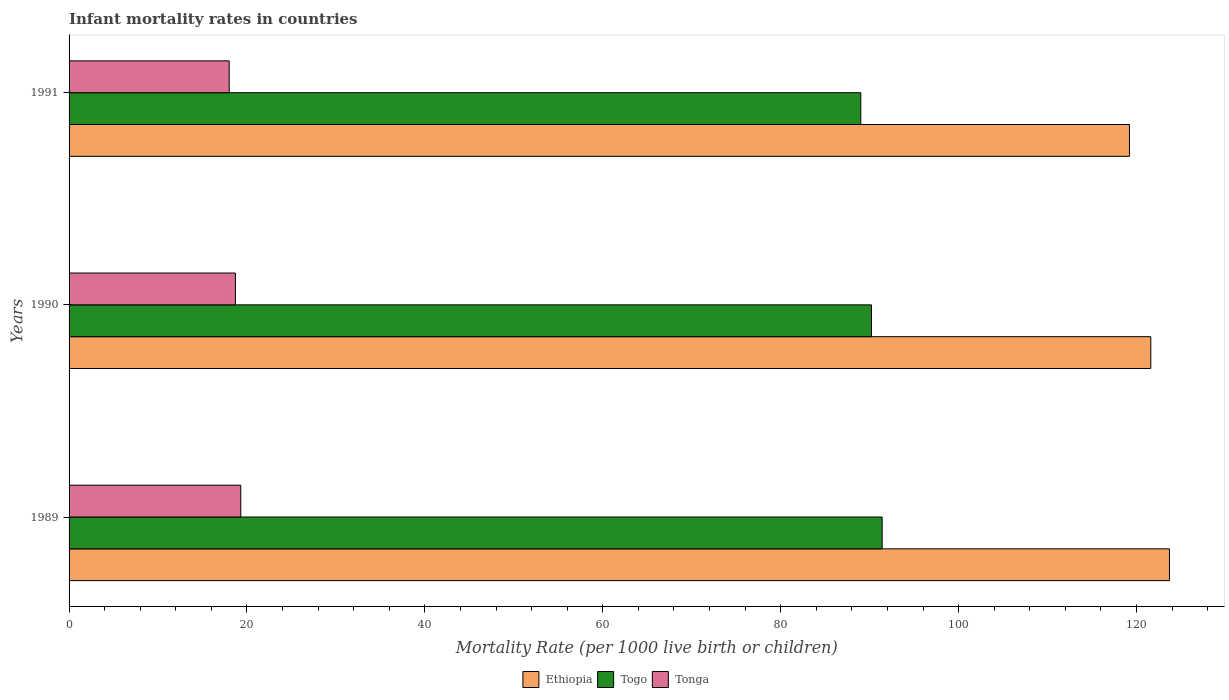How many groups of bars are there?
Provide a succinct answer. 3. Are the number of bars on each tick of the Y-axis equal?
Your answer should be very brief. Yes. How many bars are there on the 2nd tick from the top?
Make the answer very short. 3. How many bars are there on the 3rd tick from the bottom?
Provide a succinct answer. 3. What is the label of the 2nd group of bars from the top?
Ensure brevity in your answer.  1990. What is the infant mortality rate in Togo in 1989?
Offer a terse response. 91.4. Across all years, what is the maximum infant mortality rate in Tonga?
Give a very brief answer. 19.3. Across all years, what is the minimum infant mortality rate in Togo?
Offer a very short reply. 89. In which year was the infant mortality rate in Ethiopia maximum?
Provide a succinct answer. 1989. What is the total infant mortality rate in Ethiopia in the graph?
Provide a short and direct response. 364.5. What is the difference between the infant mortality rate in Tonga in 1989 and that in 1990?
Give a very brief answer. 0.6. What is the difference between the infant mortality rate in Ethiopia in 1990 and the infant mortality rate in Togo in 1991?
Offer a very short reply. 32.6. What is the average infant mortality rate in Tonga per year?
Offer a terse response. 18.67. In the year 1990, what is the difference between the infant mortality rate in Ethiopia and infant mortality rate in Togo?
Your answer should be compact. 31.4. What is the ratio of the infant mortality rate in Togo in 1989 to that in 1990?
Provide a succinct answer. 1.01. Is the infant mortality rate in Ethiopia in 1989 less than that in 1990?
Keep it short and to the point. No. Is the difference between the infant mortality rate in Ethiopia in 1990 and 1991 greater than the difference between the infant mortality rate in Togo in 1990 and 1991?
Give a very brief answer. Yes. What is the difference between the highest and the second highest infant mortality rate in Ethiopia?
Your answer should be compact. 2.1. What is the difference between the highest and the lowest infant mortality rate in Tonga?
Provide a short and direct response. 1.3. In how many years, is the infant mortality rate in Tonga greater than the average infant mortality rate in Tonga taken over all years?
Your response must be concise. 2. Is the sum of the infant mortality rate in Togo in 1989 and 1991 greater than the maximum infant mortality rate in Ethiopia across all years?
Offer a very short reply. Yes. What does the 2nd bar from the top in 1990 represents?
Your response must be concise. Togo. What does the 3rd bar from the bottom in 1989 represents?
Give a very brief answer. Tonga. Is it the case that in every year, the sum of the infant mortality rate in Ethiopia and infant mortality rate in Tonga is greater than the infant mortality rate in Togo?
Your answer should be compact. Yes. How many bars are there?
Your answer should be very brief. 9. How many years are there in the graph?
Provide a short and direct response. 3. Does the graph contain any zero values?
Your response must be concise. No. How are the legend labels stacked?
Your response must be concise. Horizontal. What is the title of the graph?
Offer a terse response. Infant mortality rates in countries. What is the label or title of the X-axis?
Your answer should be compact. Mortality Rate (per 1000 live birth or children). What is the label or title of the Y-axis?
Provide a short and direct response. Years. What is the Mortality Rate (per 1000 live birth or children) of Ethiopia in 1989?
Provide a short and direct response. 123.7. What is the Mortality Rate (per 1000 live birth or children) in Togo in 1989?
Give a very brief answer. 91.4. What is the Mortality Rate (per 1000 live birth or children) in Tonga in 1989?
Provide a short and direct response. 19.3. What is the Mortality Rate (per 1000 live birth or children) of Ethiopia in 1990?
Your answer should be compact. 121.6. What is the Mortality Rate (per 1000 live birth or children) of Togo in 1990?
Your answer should be very brief. 90.2. What is the Mortality Rate (per 1000 live birth or children) in Ethiopia in 1991?
Give a very brief answer. 119.2. What is the Mortality Rate (per 1000 live birth or children) in Togo in 1991?
Your answer should be compact. 89. What is the Mortality Rate (per 1000 live birth or children) in Tonga in 1991?
Ensure brevity in your answer.  18. Across all years, what is the maximum Mortality Rate (per 1000 live birth or children) of Ethiopia?
Your answer should be very brief. 123.7. Across all years, what is the maximum Mortality Rate (per 1000 live birth or children) of Togo?
Make the answer very short. 91.4. Across all years, what is the maximum Mortality Rate (per 1000 live birth or children) in Tonga?
Keep it short and to the point. 19.3. Across all years, what is the minimum Mortality Rate (per 1000 live birth or children) of Ethiopia?
Offer a very short reply. 119.2. Across all years, what is the minimum Mortality Rate (per 1000 live birth or children) in Togo?
Keep it short and to the point. 89. What is the total Mortality Rate (per 1000 live birth or children) in Ethiopia in the graph?
Provide a succinct answer. 364.5. What is the total Mortality Rate (per 1000 live birth or children) in Togo in the graph?
Provide a short and direct response. 270.6. What is the total Mortality Rate (per 1000 live birth or children) in Tonga in the graph?
Your answer should be compact. 56. What is the difference between the Mortality Rate (per 1000 live birth or children) in Tonga in 1989 and that in 1990?
Provide a succinct answer. 0.6. What is the difference between the Mortality Rate (per 1000 live birth or children) in Ethiopia in 1989 and that in 1991?
Your response must be concise. 4.5. What is the difference between the Mortality Rate (per 1000 live birth or children) in Tonga in 1989 and that in 1991?
Your answer should be compact. 1.3. What is the difference between the Mortality Rate (per 1000 live birth or children) of Togo in 1990 and that in 1991?
Ensure brevity in your answer.  1.2. What is the difference between the Mortality Rate (per 1000 live birth or children) in Ethiopia in 1989 and the Mortality Rate (per 1000 live birth or children) in Togo in 1990?
Your response must be concise. 33.5. What is the difference between the Mortality Rate (per 1000 live birth or children) of Ethiopia in 1989 and the Mortality Rate (per 1000 live birth or children) of Tonga in 1990?
Make the answer very short. 105. What is the difference between the Mortality Rate (per 1000 live birth or children) of Togo in 1989 and the Mortality Rate (per 1000 live birth or children) of Tonga in 1990?
Keep it short and to the point. 72.7. What is the difference between the Mortality Rate (per 1000 live birth or children) in Ethiopia in 1989 and the Mortality Rate (per 1000 live birth or children) in Togo in 1991?
Offer a terse response. 34.7. What is the difference between the Mortality Rate (per 1000 live birth or children) in Ethiopia in 1989 and the Mortality Rate (per 1000 live birth or children) in Tonga in 1991?
Offer a very short reply. 105.7. What is the difference between the Mortality Rate (per 1000 live birth or children) in Togo in 1989 and the Mortality Rate (per 1000 live birth or children) in Tonga in 1991?
Provide a succinct answer. 73.4. What is the difference between the Mortality Rate (per 1000 live birth or children) of Ethiopia in 1990 and the Mortality Rate (per 1000 live birth or children) of Togo in 1991?
Make the answer very short. 32.6. What is the difference between the Mortality Rate (per 1000 live birth or children) in Ethiopia in 1990 and the Mortality Rate (per 1000 live birth or children) in Tonga in 1991?
Provide a short and direct response. 103.6. What is the difference between the Mortality Rate (per 1000 live birth or children) of Togo in 1990 and the Mortality Rate (per 1000 live birth or children) of Tonga in 1991?
Make the answer very short. 72.2. What is the average Mortality Rate (per 1000 live birth or children) of Ethiopia per year?
Offer a terse response. 121.5. What is the average Mortality Rate (per 1000 live birth or children) of Togo per year?
Your answer should be very brief. 90.2. What is the average Mortality Rate (per 1000 live birth or children) of Tonga per year?
Your response must be concise. 18.67. In the year 1989, what is the difference between the Mortality Rate (per 1000 live birth or children) in Ethiopia and Mortality Rate (per 1000 live birth or children) in Togo?
Your response must be concise. 32.3. In the year 1989, what is the difference between the Mortality Rate (per 1000 live birth or children) of Ethiopia and Mortality Rate (per 1000 live birth or children) of Tonga?
Offer a terse response. 104.4. In the year 1989, what is the difference between the Mortality Rate (per 1000 live birth or children) of Togo and Mortality Rate (per 1000 live birth or children) of Tonga?
Provide a short and direct response. 72.1. In the year 1990, what is the difference between the Mortality Rate (per 1000 live birth or children) of Ethiopia and Mortality Rate (per 1000 live birth or children) of Togo?
Provide a succinct answer. 31.4. In the year 1990, what is the difference between the Mortality Rate (per 1000 live birth or children) of Ethiopia and Mortality Rate (per 1000 live birth or children) of Tonga?
Offer a very short reply. 102.9. In the year 1990, what is the difference between the Mortality Rate (per 1000 live birth or children) in Togo and Mortality Rate (per 1000 live birth or children) in Tonga?
Offer a terse response. 71.5. In the year 1991, what is the difference between the Mortality Rate (per 1000 live birth or children) in Ethiopia and Mortality Rate (per 1000 live birth or children) in Togo?
Keep it short and to the point. 30.2. In the year 1991, what is the difference between the Mortality Rate (per 1000 live birth or children) of Ethiopia and Mortality Rate (per 1000 live birth or children) of Tonga?
Offer a terse response. 101.2. What is the ratio of the Mortality Rate (per 1000 live birth or children) in Ethiopia in 1989 to that in 1990?
Give a very brief answer. 1.02. What is the ratio of the Mortality Rate (per 1000 live birth or children) in Togo in 1989 to that in 1990?
Ensure brevity in your answer.  1.01. What is the ratio of the Mortality Rate (per 1000 live birth or children) of Tonga in 1989 to that in 1990?
Keep it short and to the point. 1.03. What is the ratio of the Mortality Rate (per 1000 live birth or children) of Ethiopia in 1989 to that in 1991?
Keep it short and to the point. 1.04. What is the ratio of the Mortality Rate (per 1000 live birth or children) of Tonga in 1989 to that in 1991?
Offer a terse response. 1.07. What is the ratio of the Mortality Rate (per 1000 live birth or children) in Ethiopia in 1990 to that in 1991?
Your answer should be compact. 1.02. What is the ratio of the Mortality Rate (per 1000 live birth or children) in Togo in 1990 to that in 1991?
Offer a very short reply. 1.01. What is the ratio of the Mortality Rate (per 1000 live birth or children) of Tonga in 1990 to that in 1991?
Your response must be concise. 1.04. What is the difference between the highest and the second highest Mortality Rate (per 1000 live birth or children) in Tonga?
Offer a terse response. 0.6. What is the difference between the highest and the lowest Mortality Rate (per 1000 live birth or children) of Tonga?
Keep it short and to the point. 1.3. 